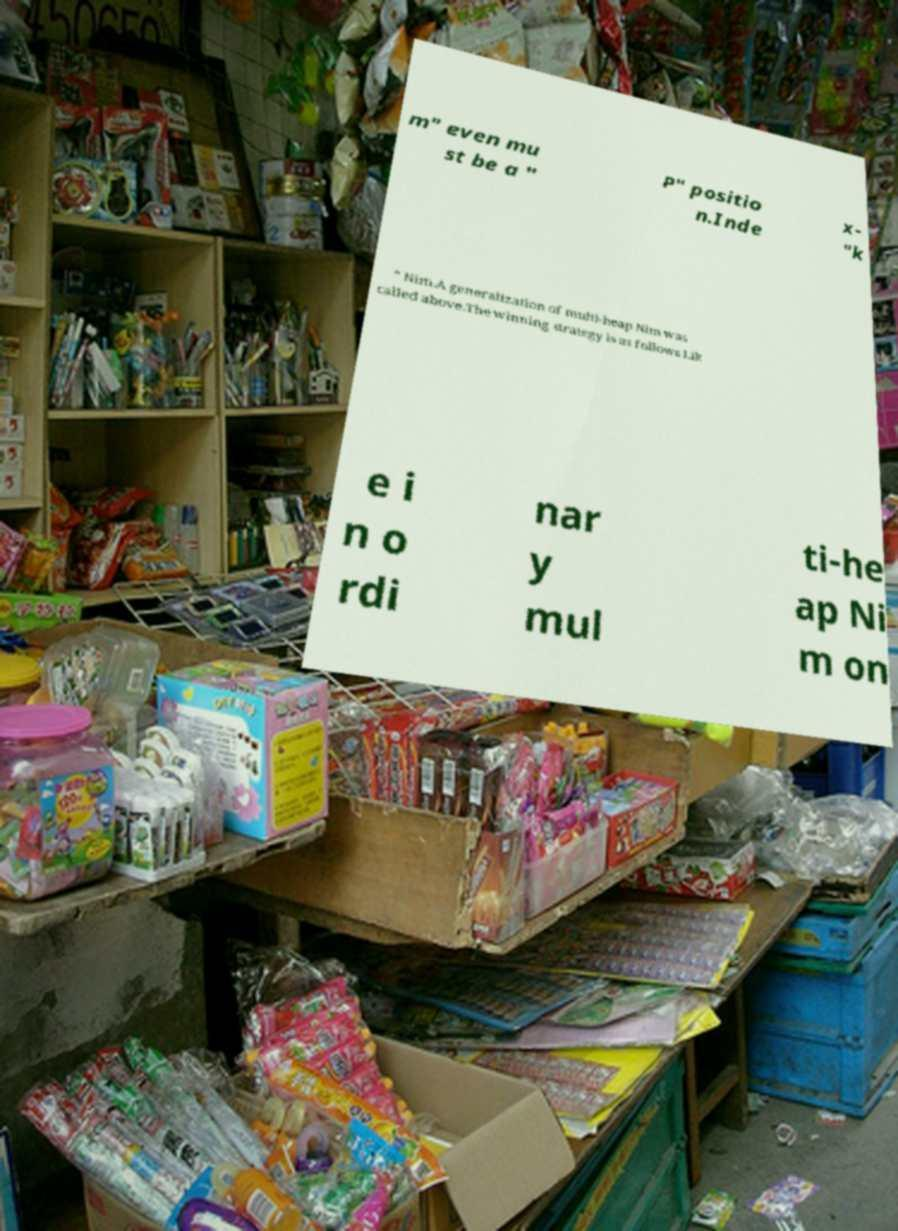For documentation purposes, I need the text within this image transcribed. Could you provide that? m" even mu st be a " P" positio n.Inde x- "k " Nim.A generalization of multi-heap Nim was called above.The winning strategy is as follows Lik e i n o rdi nar y mul ti-he ap Ni m on 